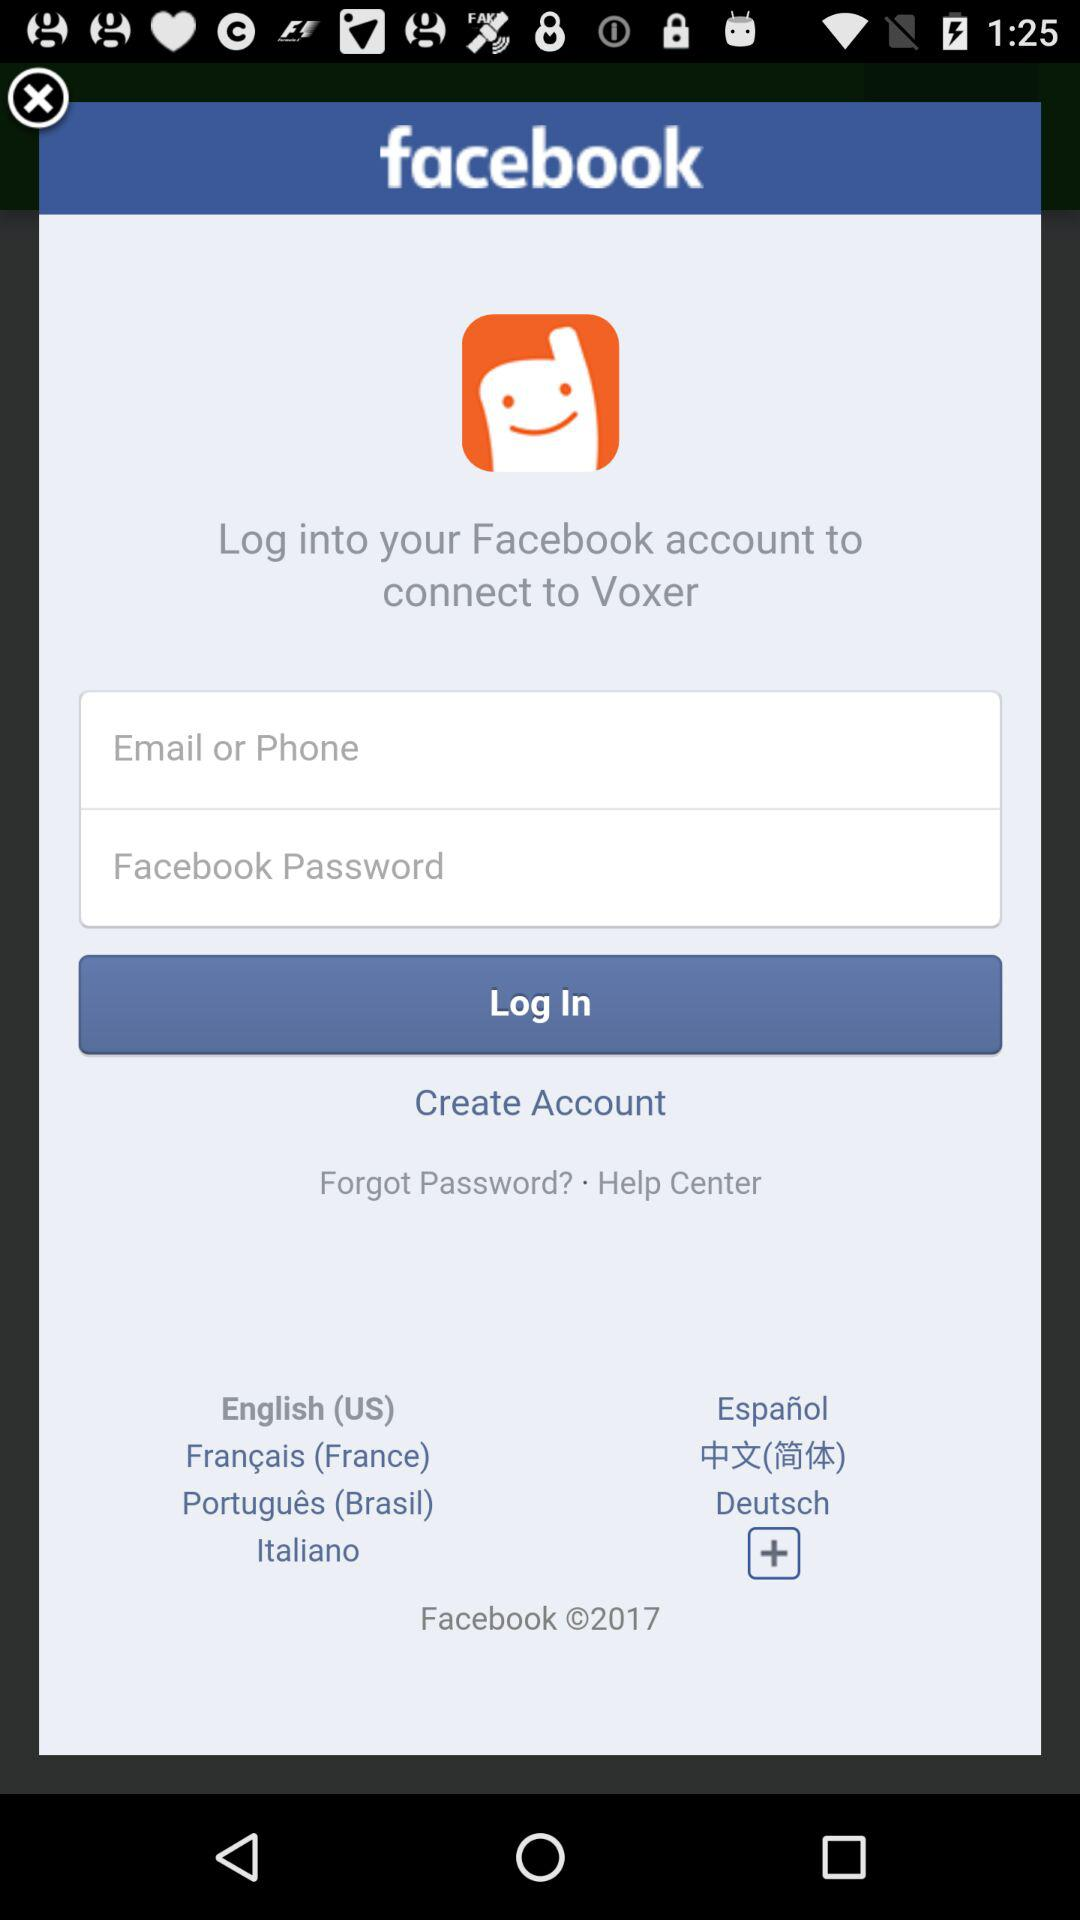What application is used to connect? The application is "Facebook". 